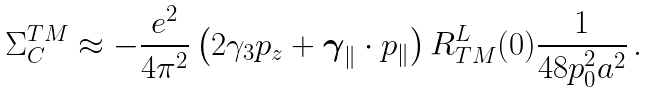Convert formula to latex. <formula><loc_0><loc_0><loc_500><loc_500>\Sigma ^ { T M } _ { C } \approx - \frac { e ^ { 2 } } { 4 \pi ^ { 2 } } \left ( 2 \gamma _ { 3 } p _ { z } + \boldsymbol \gamma _ { \| } \cdot { p } _ { \| } \right ) R ^ { L } _ { T M } ( 0 ) \frac { 1 } { 4 8 p _ { 0 } ^ { 2 } a ^ { 2 } } \, .</formula> 